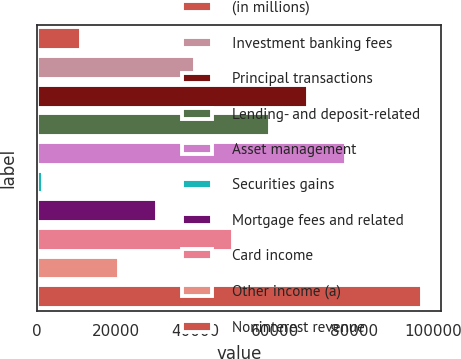<chart> <loc_0><loc_0><loc_500><loc_500><bar_chart><fcel>(in millions)<fcel>Investment banking fees<fcel>Principal transactions<fcel>Lending- and deposit-related<fcel>Asset management<fcel>Securities gains<fcel>Mortgage fees and related<fcel>Card income<fcel>Other income (a)<fcel>Noninterest revenue<nl><fcel>11157.1<fcel>39849.4<fcel>68541.7<fcel>58977.6<fcel>78105.8<fcel>1593<fcel>30285.3<fcel>49413.5<fcel>20721.2<fcel>97234<nl></chart> 